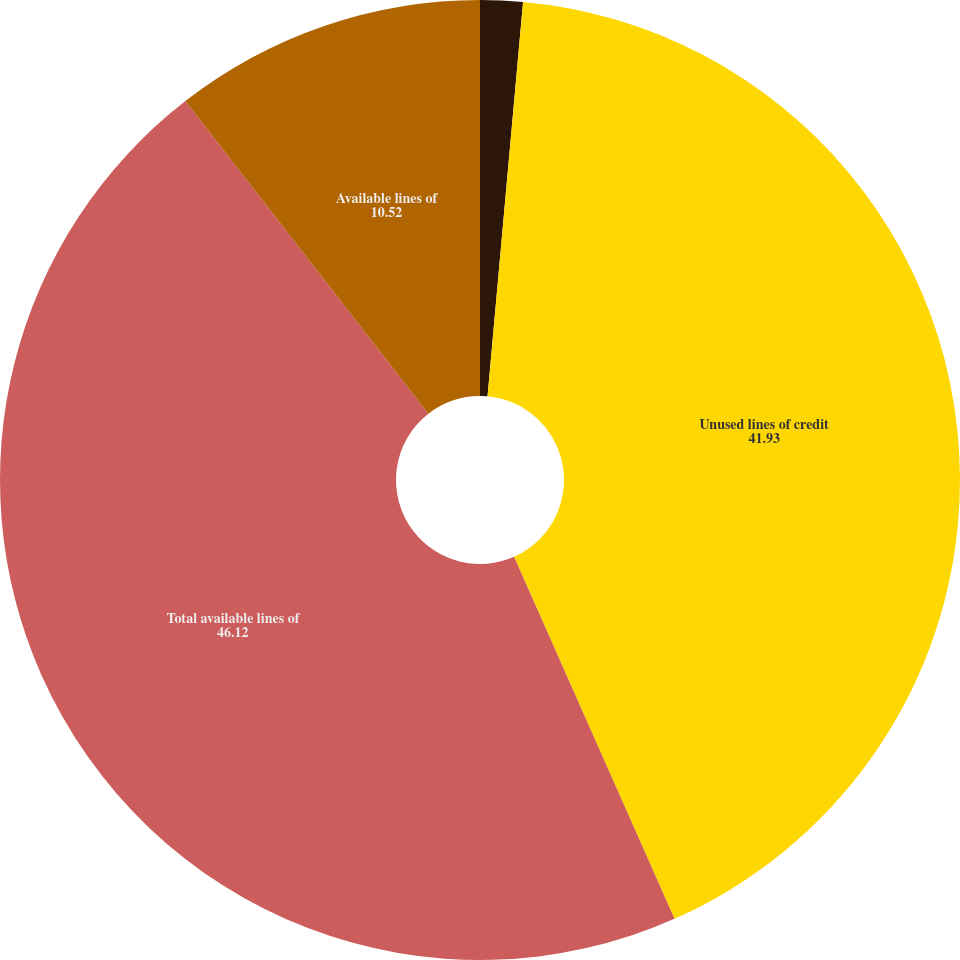Convert chart to OTSL. <chart><loc_0><loc_0><loc_500><loc_500><pie_chart><fcel>Used lines of credit<fcel>Unused lines of credit<fcel>Total available lines of<fcel>Available lines of<nl><fcel>1.43%<fcel>41.93%<fcel>46.12%<fcel>10.52%<nl></chart> 